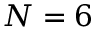<formula> <loc_0><loc_0><loc_500><loc_500>N = 6</formula> 